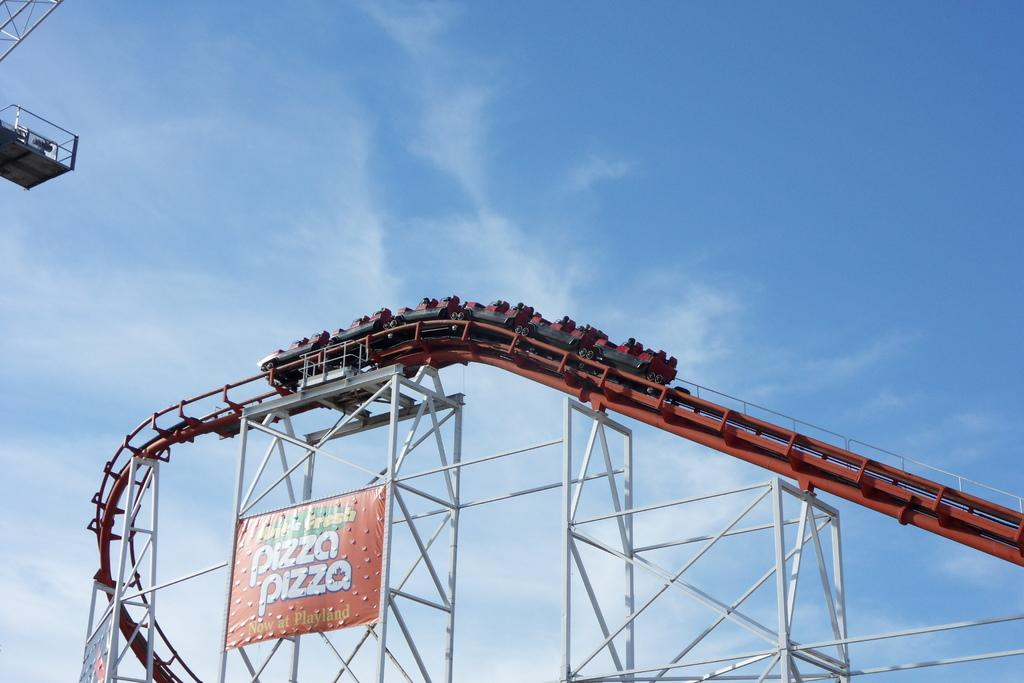<image>
Relay a brief, clear account of the picture shown. A large rollercoaster with a pizza pizza sign on it. 